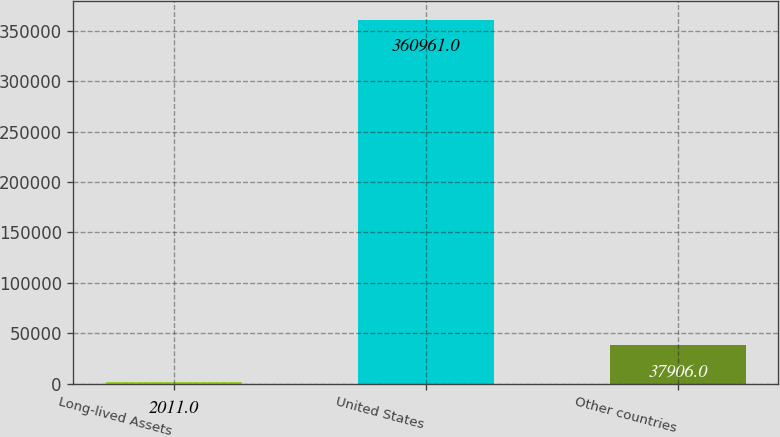Convert chart to OTSL. <chart><loc_0><loc_0><loc_500><loc_500><bar_chart><fcel>Long-lived Assets<fcel>United States<fcel>Other countries<nl><fcel>2011<fcel>360961<fcel>37906<nl></chart> 